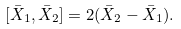<formula> <loc_0><loc_0><loc_500><loc_500>[ \bar { X } _ { 1 } , \bar { X } _ { 2 } ] = 2 ( \bar { X } _ { 2 } - \bar { X } _ { 1 } ) .</formula> 